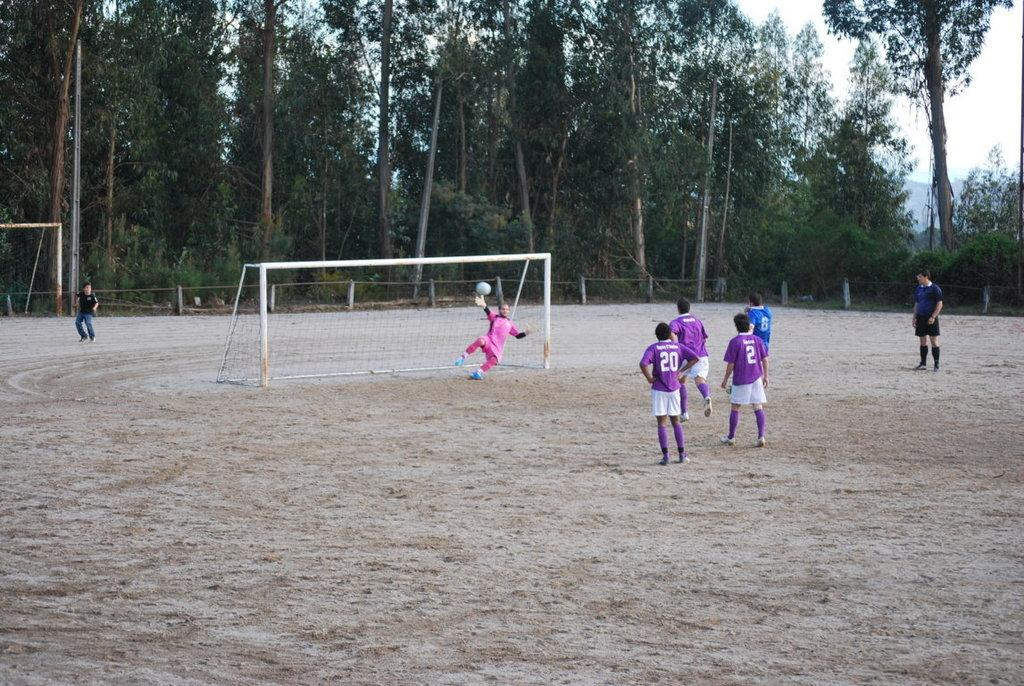<image>
Relay a brief, clear account of the picture shown. a player in purple with the number 20 on it 